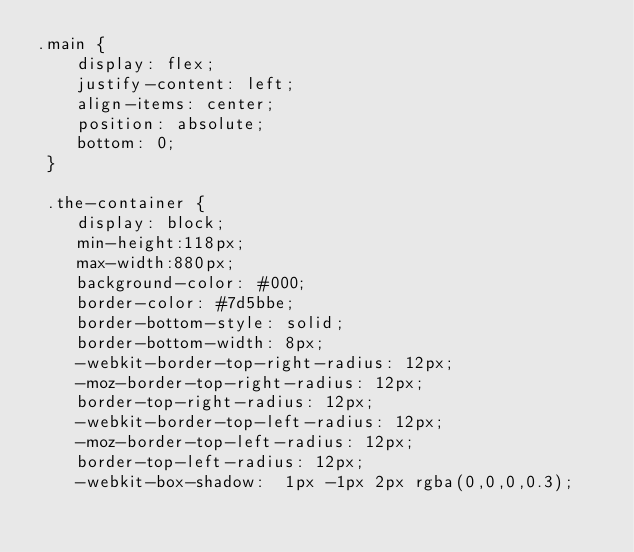Convert code to text. <code><loc_0><loc_0><loc_500><loc_500><_CSS_>.main {
    display: flex;
    justify-content: left;
    align-items: center;
    position: absolute;
    bottom: 0;
 }
 
 .the-container {
    display: block;
    min-height:118px;
    max-width:880px;
    background-color: #000;
    border-color: #7d5bbe;
    border-bottom-style: solid;
    border-bottom-width: 8px;
    -webkit-border-top-right-radius: 12px;
    -moz-border-top-right-radius: 12px;
    border-top-right-radius: 12px;
    -webkit-border-top-left-radius: 12px;
    -moz-border-top-left-radius: 12px;
    border-top-left-radius: 12px;
    -webkit-box-shadow:  1px -1px 2px rgba(0,0,0,0.3);</code> 